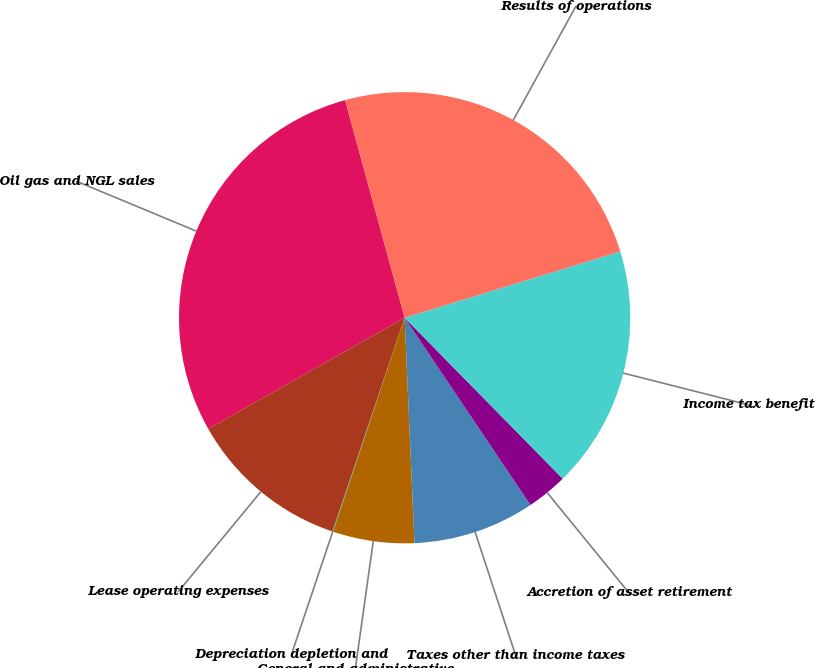Convert chart to OTSL. <chart><loc_0><loc_0><loc_500><loc_500><pie_chart><fcel>Oil gas and NGL sales<fcel>Lease operating expenses<fcel>Depreciation depletion and<fcel>General and administrative<fcel>Taxes other than income taxes<fcel>Accretion of asset retirement<fcel>Income tax benefit<fcel>Results of operations<nl><fcel>28.95%<fcel>11.61%<fcel>0.05%<fcel>5.83%<fcel>8.72%<fcel>2.94%<fcel>17.39%<fcel>24.5%<nl></chart> 